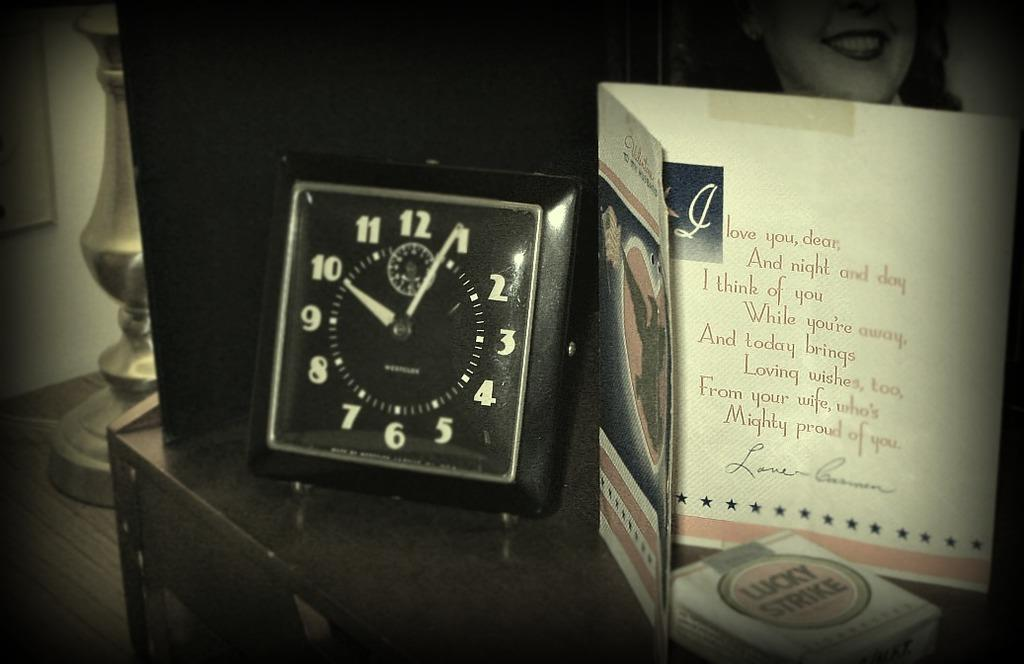<image>
Describe the image concisely. A bedside table contains a greeting card, pack of Lucky Strike cigarettes, and a clock that indicates 10:05. 